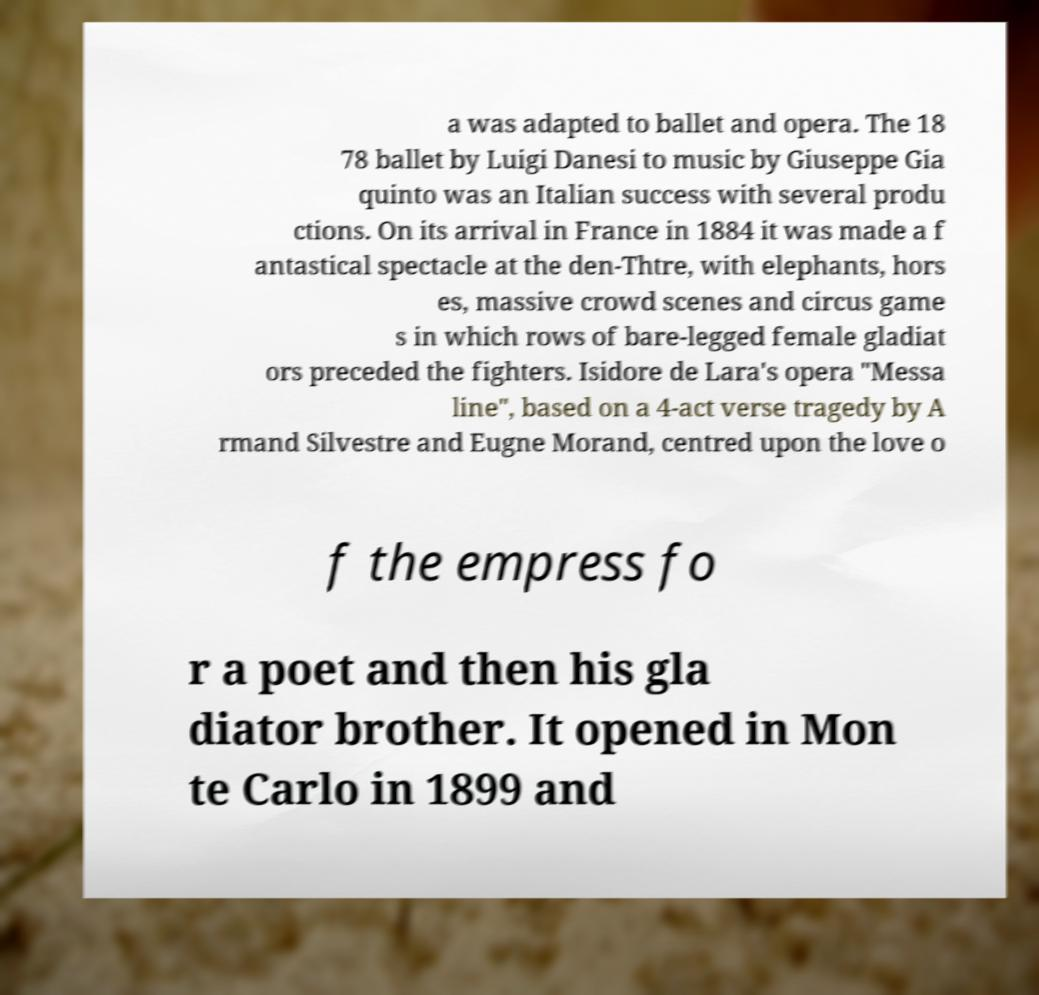For documentation purposes, I need the text within this image transcribed. Could you provide that? a was adapted to ballet and opera. The 18 78 ballet by Luigi Danesi to music by Giuseppe Gia quinto was an Italian success with several produ ctions. On its arrival in France in 1884 it was made a f antastical spectacle at the den-Thtre, with elephants, hors es, massive crowd scenes and circus game s in which rows of bare-legged female gladiat ors preceded the fighters. Isidore de Lara's opera "Messa line", based on a 4-act verse tragedy by A rmand Silvestre and Eugne Morand, centred upon the love o f the empress fo r a poet and then his gla diator brother. It opened in Mon te Carlo in 1899 and 